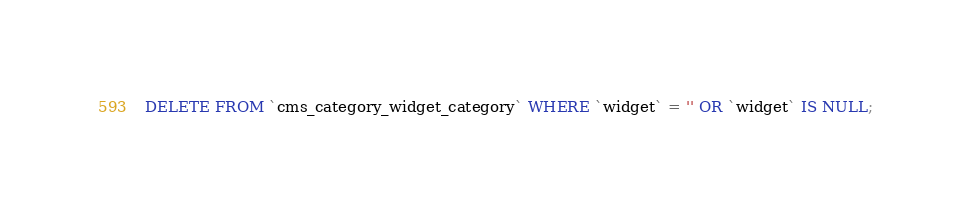Convert code to text. <code><loc_0><loc_0><loc_500><loc_500><_SQL_>DELETE FROM `cms_category_widget_category` WHERE `widget` = '' OR `widget` IS NULL;</code> 